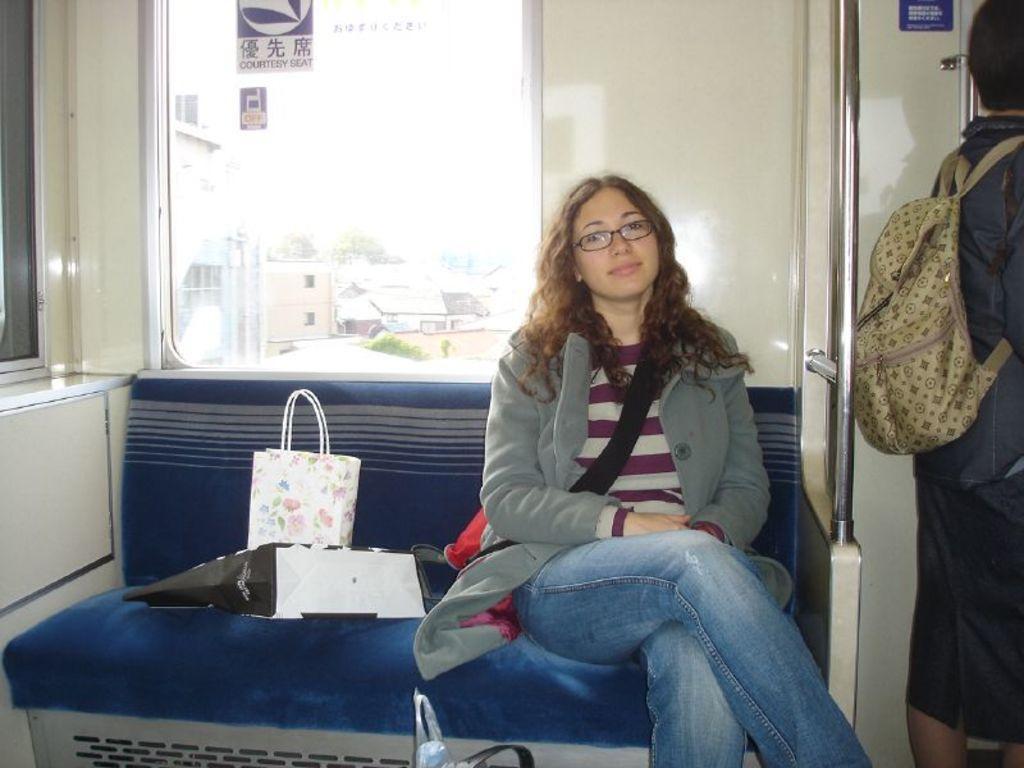Can you describe this image briefly? In the photo there is a woman who is sitting on the sofa there are some covers beside her ,to her right side there is another woman standing and wearing a bag, in the background there is a window and there are some buildings outside the window. 